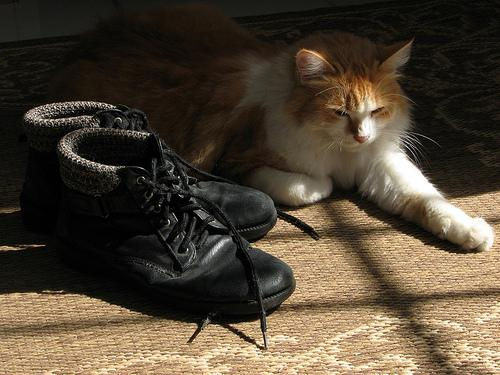What complex reasoning clue can be derived from the image regarding the shoes' purpose? The untied shoe laces on the black shoes might suggest that they were recently taken off or are about to be put on by someone. Provide a brief description of the image focusing on the cat and its appearance. The image shows a golden brown and white long hair cat, with pointy ears and a pink nose, laying on the floor and relaxing. It has its eyes closed and paws stretched out. Describe the interaction between the cat and the shoes in the image. The cat is laying on the floor next to the pair of black shoes, but it is not directly interacting with them. What are the main objects depicted in the image and their relationship to each other? The main objects in the image are a pair of black shoes on the floor, a cat on the carpet, and the carpet itself. The cat is positioned next to the shoes, and both the shoes and the cat are on the carpet. What is the main sentiment you can identify from the image? The image feels relaxed and peaceful, with the cat resting on the carpet next to the shoes. Evaluate the quality of the image - is it clear, detailed, or blurry? The image is clear, with detailed information about the objects, such as the cat's facial features and the shoe laces. Based on the information provided, are the shoes solid or patterned? The shoes are described as solid without any mention of patterns or designs. What is the condition of the shoe laces, and what are their colors? The shoe laces are untied, and they are black in color. How many visible cat paws can be seen in the image and how are they positioned? There are at least two visible cat paws in the image, one is outstretched and another is part of the stretched out leg and paw. How many shoes are there in the image and what color are they?  There are two shoes in the image, and they are black in color. What color are the shoes in the image? Black What type of shoes can you see in the image? A pair of black shoes or booties What does the rug in the image look like? It is a tan-colored, tightly woven area rug with a white design. Spot the plate of cookies near the shoes and describe what kind of cookies are on it. No, it's not mentioned in the image. Which of the following is most accurate about the shoes in the image? A) They're tied B) They're untied C) They have no laces B) They're untied Identify and describe the main objects in the image. The scene includes a tan and white cat on the carpet next to a pair of untied, black shoes. Can you detect a window pane in the image? If so, state its position. Yes, there's a shadow of a window pane molding cast on the floor. Briefly describe the cat's physical attributes. The cat is orange and white, has long hair, pointy ears, and whiskers illuminated by the sun. What is the relationship between the cat and the black shoes? The cat is next to a pair of black shoes. Convey the overall scene appearing in this image with a creative tone. A peaceful and serene moment unfolds as an orange-white cat, fatigued from its feline exploits, lays to rest beside a pair of untied, black booties that lay in quiet harmony on the sun-soaked, intricately designed carpet, thoughtfully absorbing the golden rays. What two main elements are sharing the same space in the image? A cat and a pair of black shoes are both on the carpet. Describe the carpet on the floor in this image. It is a tightly woven area rug with a white design and sun shining on it. How would you describe the design on the carpet? It has a white design and sun shining on it, creating shadows. What is the condition of the shoelaces on the shoes in the image? The shoelaces on the shoes are untied. What are the distinctive features of the cat's paws in the image? They are outstretched and belong to an orange and white cat. What color is the cat in the image? Orange and white Which of the following is present in the image? A) A dog B) A cat C) A bird B) A cat What is the cat doing in this image? The cat is laying on the floor and relaxing. Identify and explain the position and activity of the cat. The cat is lying on the floor and appears to be relaxing. 